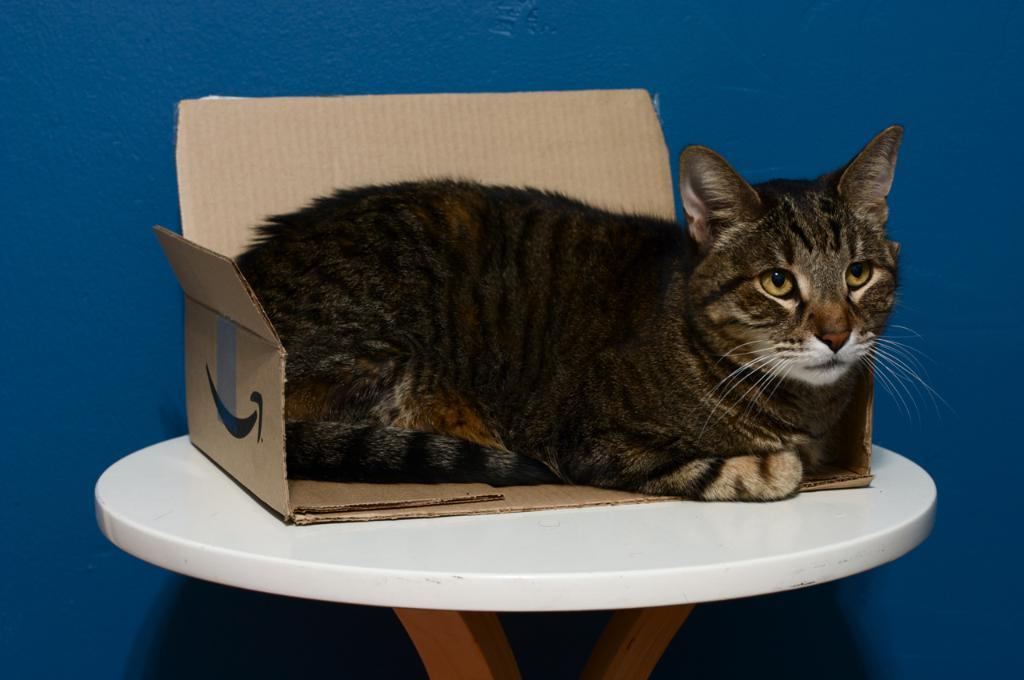What type of animal is in the image? There is a cat in the image. Where is the cat located in the image? The cat is sitting on a table. What is the name of the cat in the image? The name of the cat is not mentioned in the image, so it cannot be determined. 